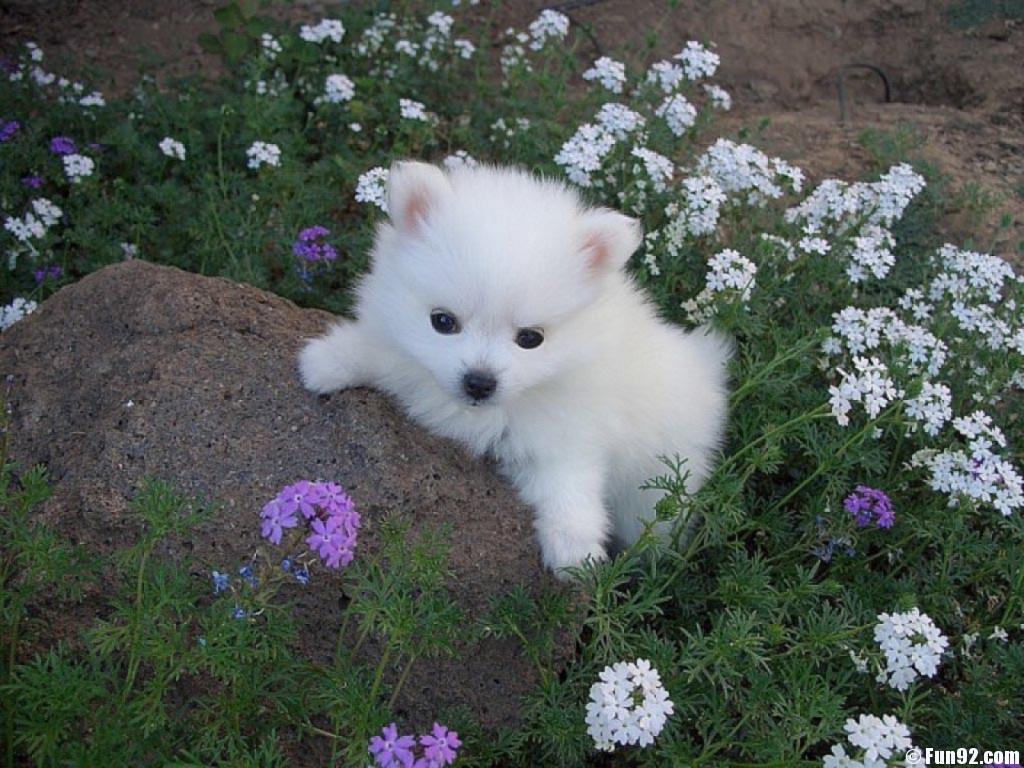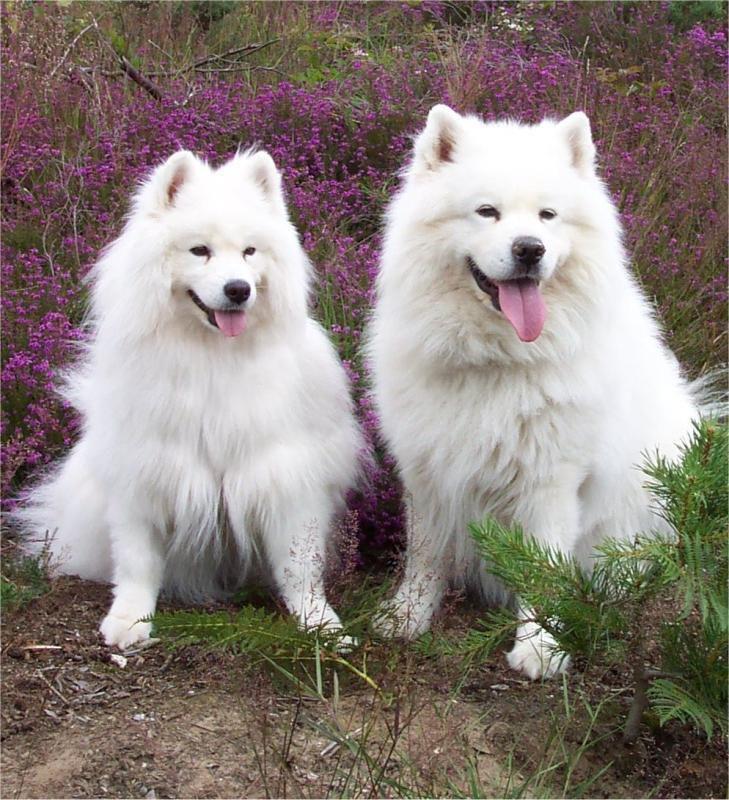The first image is the image on the left, the second image is the image on the right. Given the left and right images, does the statement "At least one dog has its mouth open." hold true? Answer yes or no. Yes. The first image is the image on the left, the second image is the image on the right. Assess this claim about the two images: "A total of three white dogs are shown, and the two dogs in one image are lookalikes, but do not closely resemble the lone dog in the other image.". Correct or not? Answer yes or no. Yes. 